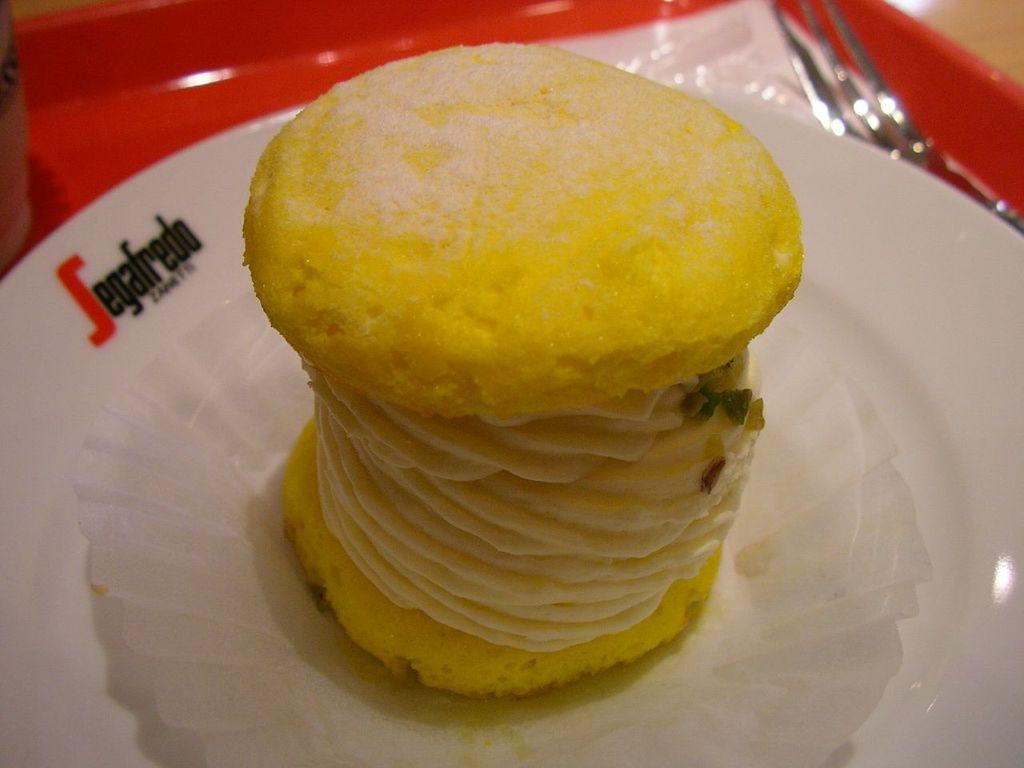What object is present in the image that can hold items? There is a tray in the image that can hold items. What is on the tray? The tray contains a paper, a fork, and a plate with food. How is the paper positioned on the tray? The paper is on the plate. What part of the room can be seen in the top right corner of the image? The top right corner of the image shows the floor. What type of advertisement can be seen on the plate in the image? There is no advertisement present on the plate in the image; it contains food. How many chairs are visible in the image? There are no chairs visible in the image. 